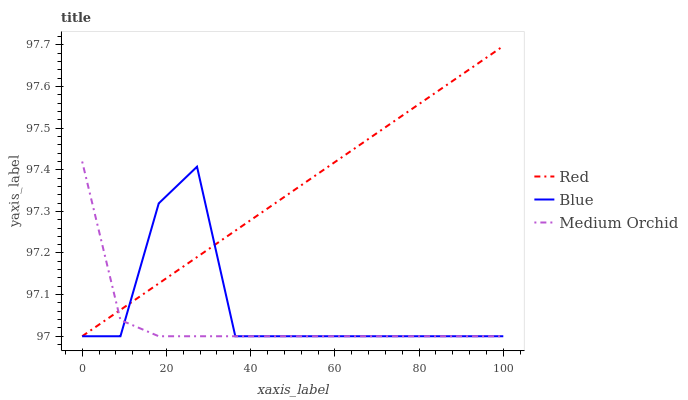Does Medium Orchid have the minimum area under the curve?
Answer yes or no. Yes. Does Red have the maximum area under the curve?
Answer yes or no. Yes. Does Red have the minimum area under the curve?
Answer yes or no. No. Does Medium Orchid have the maximum area under the curve?
Answer yes or no. No. Is Red the smoothest?
Answer yes or no. Yes. Is Blue the roughest?
Answer yes or no. Yes. Is Medium Orchid the smoothest?
Answer yes or no. No. Is Medium Orchid the roughest?
Answer yes or no. No. Does Blue have the lowest value?
Answer yes or no. Yes. Does Red have the highest value?
Answer yes or no. Yes. Does Medium Orchid have the highest value?
Answer yes or no. No. Does Blue intersect Red?
Answer yes or no. Yes. Is Blue less than Red?
Answer yes or no. No. Is Blue greater than Red?
Answer yes or no. No. 